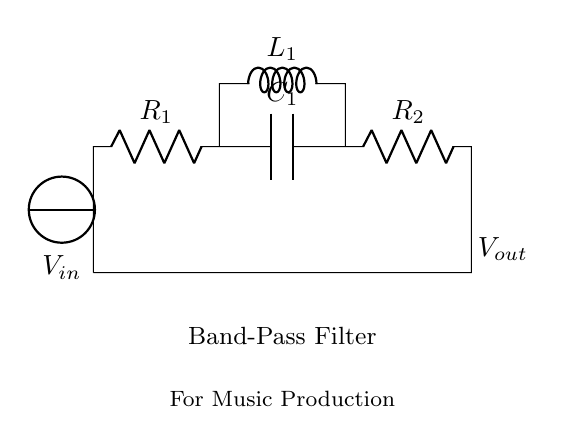What are the components in the circuit? The circuit contains two resistors, a capacitor, an inductor, and a voltage source. Each component has a specific role in filtering the frequency signals.
Answer: Resistors, capacitor, inductor, voltage source What is the function of the inductor? The inductor in this band-pass filter allows certain frequencies to pass while rejecting others. It is essential in determining the filter's behavior at higher frequencies.
Answer: Filtering higher frequencies What is the value of the output voltage? The output voltage is labeled as Vout in the diagram, which typically represents the voltage across the output of the band-pass filter. The exact value depends on the input voltage and other components' values.
Answer: Vout What type of filter is this circuit? The circuit displayed is a band-pass filter designed to isolate specific frequency ranges in audio signals during music production. This is achieved by combining both high-pass and low-pass characteristics.
Answer: Band-pass filter How many resistors are present in the circuit? There are two resistors in the circuit, identified as R1 and R2, connected in series between the capacitor and the voltage source.
Answer: Two resistors Which component would affect low-frequency signals? The capacitor, C1, plays a crucial role in affecting low-frequency signals since it blocks DC and allows AC signals to pass through, determining the lower cutoff frequency of the filter.
Answer: Capacitor What is the overall purpose of this filter in music production? The band-pass filter is used in music production to isolate specific frequency ranges, enhancing particular audio signals while reducing unwanted noise or frequencies. This allows for clearer sound mixing and mastering.
Answer: Isolate specific frequency ranges 